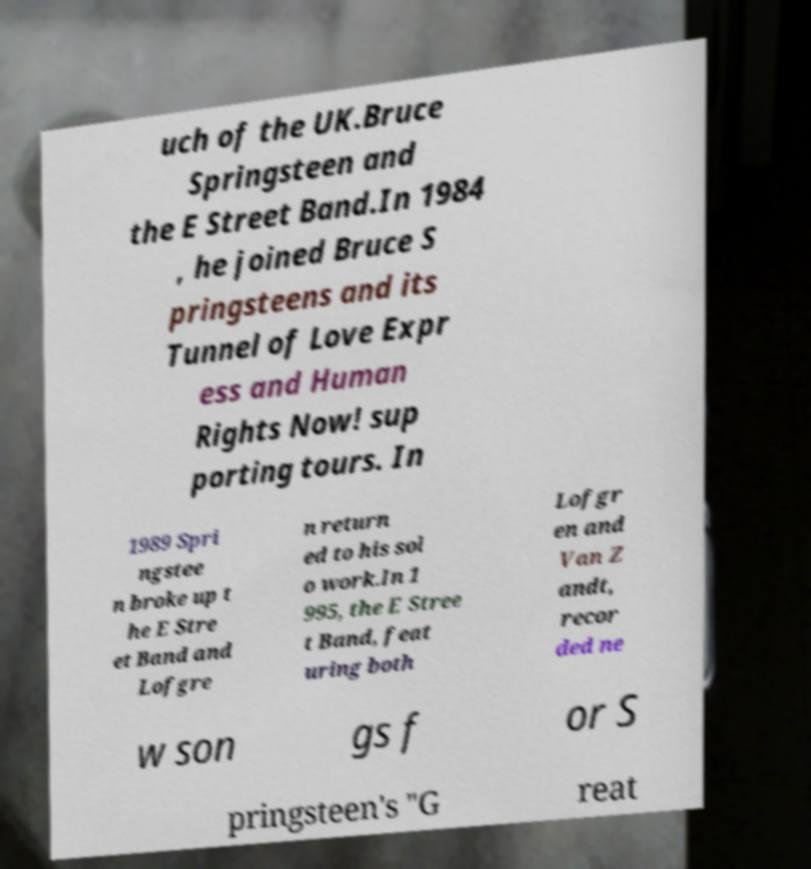There's text embedded in this image that I need extracted. Can you transcribe it verbatim? uch of the UK.Bruce Springsteen and the E Street Band.In 1984 , he joined Bruce S pringsteens and its Tunnel of Love Expr ess and Human Rights Now! sup porting tours. In 1989 Spri ngstee n broke up t he E Stre et Band and Lofgre n return ed to his sol o work.In 1 995, the E Stree t Band, feat uring both Lofgr en and Van Z andt, recor ded ne w son gs f or S pringsteen's "G reat 